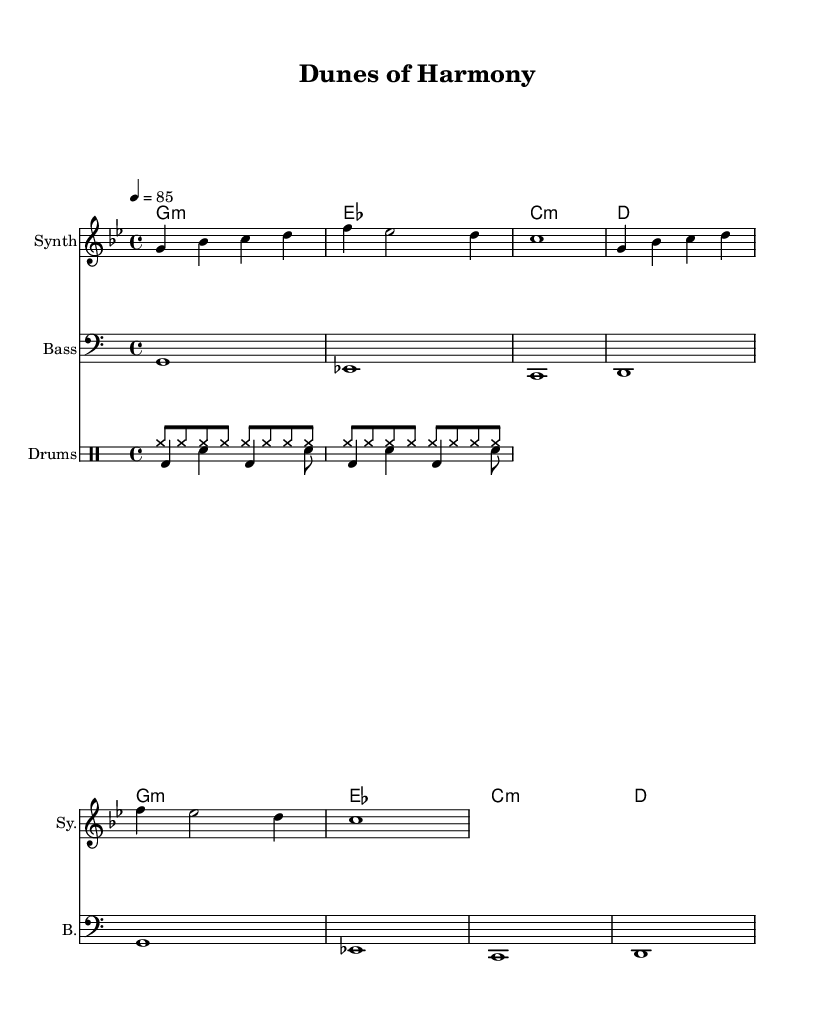What is the key signature of this music? The key signature is indicated at the beginning of the score. In this case, there are two flats in the key signature, which identifies it as G minor.
Answer: G minor What is the time signature of this music? The time signature is shown at the beginning, represented by the fraction 4/4, which indicates that there are four beats per measure.
Answer: 4/4 What is the tempo marking for this piece? The tempo marking is shown next to the time signature and states "4 = 85," meaning the quarter note should be played at a speed of 85 beats per minute.
Answer: 85 How many measures are in the melody section? By counting the vertical bar lines in the melody section, there are a total of four measures present.
Answer: 4 Which instruments are featured in this composition? The instruments are explicitly labeled in the score; they include a Synth, Bass, and Drums, as indicated at the beginning of their respective staves.
Answer: Synth, Bass, and Drums What type of drum patterns are used in this piece? By analyzing the drum section in the score, there are distinct patterns for Kick, Snare, and Hi-Hat that are typical for electronic music compositions.
Answer: Kick, Snare, and Hi-Hat 